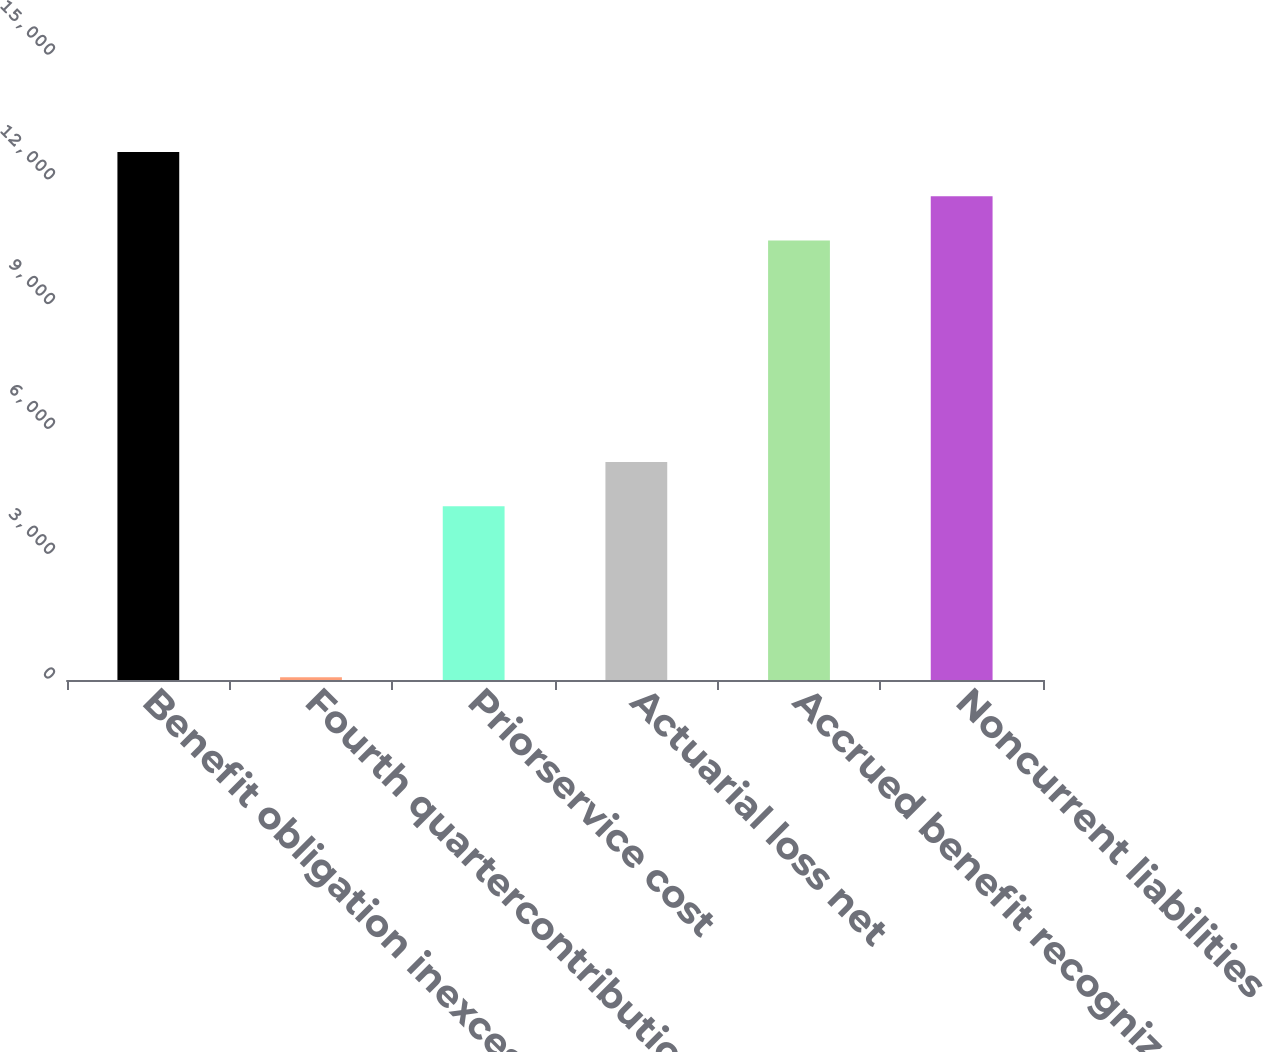<chart> <loc_0><loc_0><loc_500><loc_500><bar_chart><fcel>Benefit obligation inexcess of<fcel>Fourth quartercontributions<fcel>Priorservice cost<fcel>Actuarial loss net<fcel>Accrued benefit recognized at<fcel>Noncurrent liabilities<nl><fcel>12694.6<fcel>66<fcel>4175<fcel>5241.3<fcel>10562<fcel>11628.3<nl></chart> 